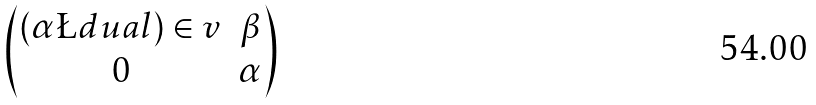<formula> <loc_0><loc_0><loc_500><loc_500>\begin{pmatrix} ( \alpha \L d u a l ) \in v & \beta \\ 0 & \alpha \end{pmatrix}</formula> 